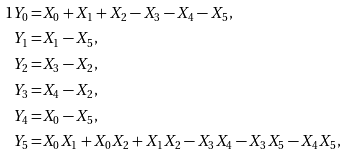<formula> <loc_0><loc_0><loc_500><loc_500>{ 1 } Y _ { 0 } = & X _ { 0 } + X _ { 1 } + X _ { 2 } - X _ { 3 } - X _ { 4 } - X _ { 5 } , \\ Y _ { 1 } = & X _ { 1 } - X _ { 5 } , \\ Y _ { 2 } = & X _ { 3 } - X _ { 2 } , \\ Y _ { 3 } = & X _ { 4 } - X _ { 2 } , \\ Y _ { 4 } = & X _ { 0 } - X _ { 5 } , \\ Y _ { 5 } = & X _ { 0 } X _ { 1 } + X _ { 0 } X _ { 2 } + X _ { 1 } X _ { 2 } - X _ { 3 } X _ { 4 } - X _ { 3 } X _ { 5 } - X _ { 4 } X _ { 5 } ,</formula> 